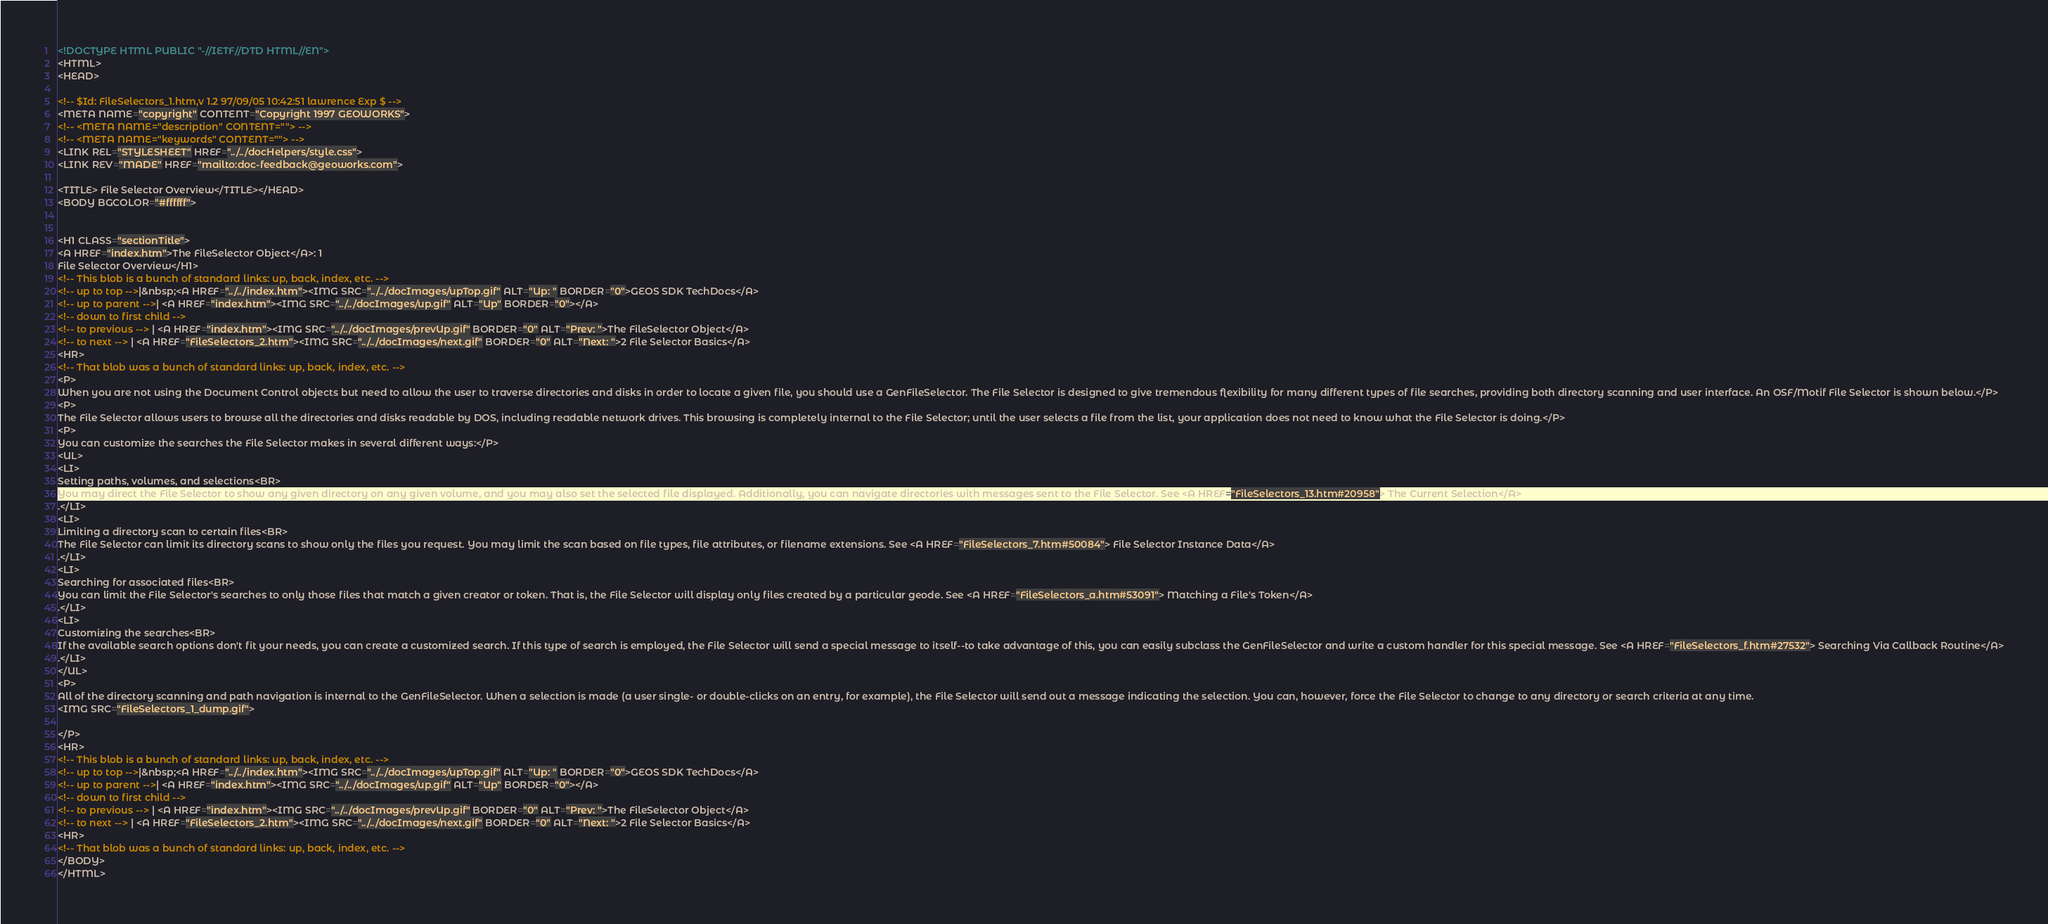<code> <loc_0><loc_0><loc_500><loc_500><_HTML_><!DOCTYPE HTML PUBLIC "-//IETF//DTD HTML//EN">
<HTML>
<HEAD>

<!-- $Id: FileSelectors_1.htm,v 1.2 97/09/05 10:42:51 lawrence Exp $ -->
<META NAME="copyright" CONTENT="Copyright 1997 GEOWORKS">
<!-- <META NAME="description" CONTENT=""> -->
<!-- <META NAME="keywords" CONTENT=""> -->
<LINK REL="STYLESHEET" HREF="../../docHelpers/style.css">
<LINK REV="MADE" HREF="mailto:doc-feedback@geoworks.com">

<TITLE> File Selector Overview</TITLE></HEAD>
<BODY BGCOLOR="#ffffff">


<H1 CLASS="sectionTitle">
<A HREF="index.htm">The FileSelector Object</A>: 1 
File Selector Overview</H1>
<!-- This blob is a bunch of standard links: up, back, index, etc. -->
<!-- up to top -->|&nbsp;<A HREF="../../index.htm"><IMG SRC="../../docImages/upTop.gif" ALT="Up: " BORDER="0">GEOS SDK TechDocs</A>
<!-- up to parent -->| <A HREF="index.htm"><IMG SRC="../../docImages/up.gif" ALT="Up" BORDER="0"></A>
<!-- down to first child --> 
<!-- to previous --> | <A HREF="index.htm"><IMG SRC="../../docImages/prevUp.gif" BORDER="0" ALT="Prev: ">The FileSelector Object</A> 
<!-- to next --> | <A HREF="FileSelectors_2.htm"><IMG SRC="../../docImages/next.gif" BORDER="0" ALT="Next: ">2 File Selector Basics</A> 
<HR>
<!-- That blob was a bunch of standard links: up, back, index, etc. -->
<P>
When you are not using the Document Control objects but need to allow the user to traverse directories and disks in order to locate a given file, you should use a GenFileSelector. The File Selector is designed to give tremendous flexibility for many different types of file searches, providing both directory scanning and user interface. An OSF/Motif File Selector is shown below.</P>
<P>
The File Selector allows users to browse all the directories and disks readable by DOS, including readable network drives. This browsing is completely internal to the File Selector; until the user selects a file from the list, your application does not need to know what the File Selector is doing.</P>
<P>
You can customize the searches the File Selector makes in several different ways:</P>
<UL>
<LI>
Setting paths, volumes, and selections<BR>
You may direct the File Selector to show any given directory on any given volume, and you may also set the selected file displayed. Additionally, you can navigate directories with messages sent to the File Selector. See <A HREF="FileSelectors_13.htm#20958"> The Current Selection</A>
.</LI>
<LI>
Limiting a directory scan to certain files<BR>
The File Selector can limit its directory scans to show only the files you request. You may limit the scan based on file types, file attributes, or filename extensions. See <A HREF="FileSelectors_7.htm#50084"> File Selector Instance Data</A>
.</LI>
<LI>
Searching for associated files<BR>
You can limit the File Selector's searches to only those files that match a given creator or token. That is, the File Selector will display only files created by a particular geode. See <A HREF="FileSelectors_a.htm#53091"> Matching a File's Token</A>
.</LI>
<LI>
Customizing the searches<BR>
If the available search options don't fit your needs, you can create a customized search. If this type of search is employed, the File Selector will send a special message to itself--to take advantage of this, you can easily subclass the GenFileSelector and write a custom handler for this special message. See <A HREF="FileSelectors_f.htm#27532"> Searching Via Callback Routine</A>
.</LI>
</UL>
<P>
All of the directory scanning and path navigation is internal to the GenFileSelector. When a selection is made (a user single- or double-clicks on an entry, for example), the File Selector will send out a message indicating the selection. You can, however, force the File Selector to change to any directory or search criteria at any time.
<IMG SRC="FileSelectors_1_dump.gif">

</P>
<HR>
<!-- This blob is a bunch of standard links: up, back, index, etc. -->
<!-- up to top -->|&nbsp;<A HREF="../../index.htm"><IMG SRC="../../docImages/upTop.gif" ALT="Up: " BORDER="0">GEOS SDK TechDocs</A>
<!-- up to parent -->| <A HREF="index.htm"><IMG SRC="../../docImages/up.gif" ALT="Up" BORDER="0"></A>
<!-- down to first child --> 
<!-- to previous --> | <A HREF="index.htm"><IMG SRC="../../docImages/prevUp.gif" BORDER="0" ALT="Prev: ">The FileSelector Object</A> 
<!-- to next --> | <A HREF="FileSelectors_2.htm"><IMG SRC="../../docImages/next.gif" BORDER="0" ALT="Next: ">2 File Selector Basics</A> 
<HR>
<!-- That blob was a bunch of standard links: up, back, index, etc. -->
</BODY>
</HTML>
</code> 